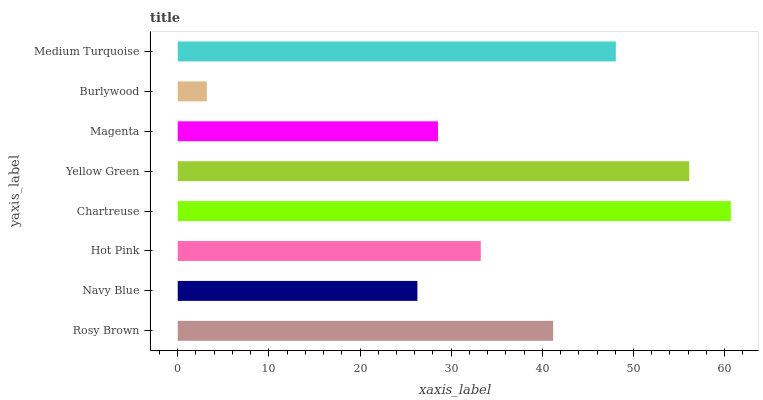Is Burlywood the minimum?
Answer yes or no. Yes. Is Chartreuse the maximum?
Answer yes or no. Yes. Is Navy Blue the minimum?
Answer yes or no. No. Is Navy Blue the maximum?
Answer yes or no. No. Is Rosy Brown greater than Navy Blue?
Answer yes or no. Yes. Is Navy Blue less than Rosy Brown?
Answer yes or no. Yes. Is Navy Blue greater than Rosy Brown?
Answer yes or no. No. Is Rosy Brown less than Navy Blue?
Answer yes or no. No. Is Rosy Brown the high median?
Answer yes or no. Yes. Is Hot Pink the low median?
Answer yes or no. Yes. Is Navy Blue the high median?
Answer yes or no. No. Is Yellow Green the low median?
Answer yes or no. No. 